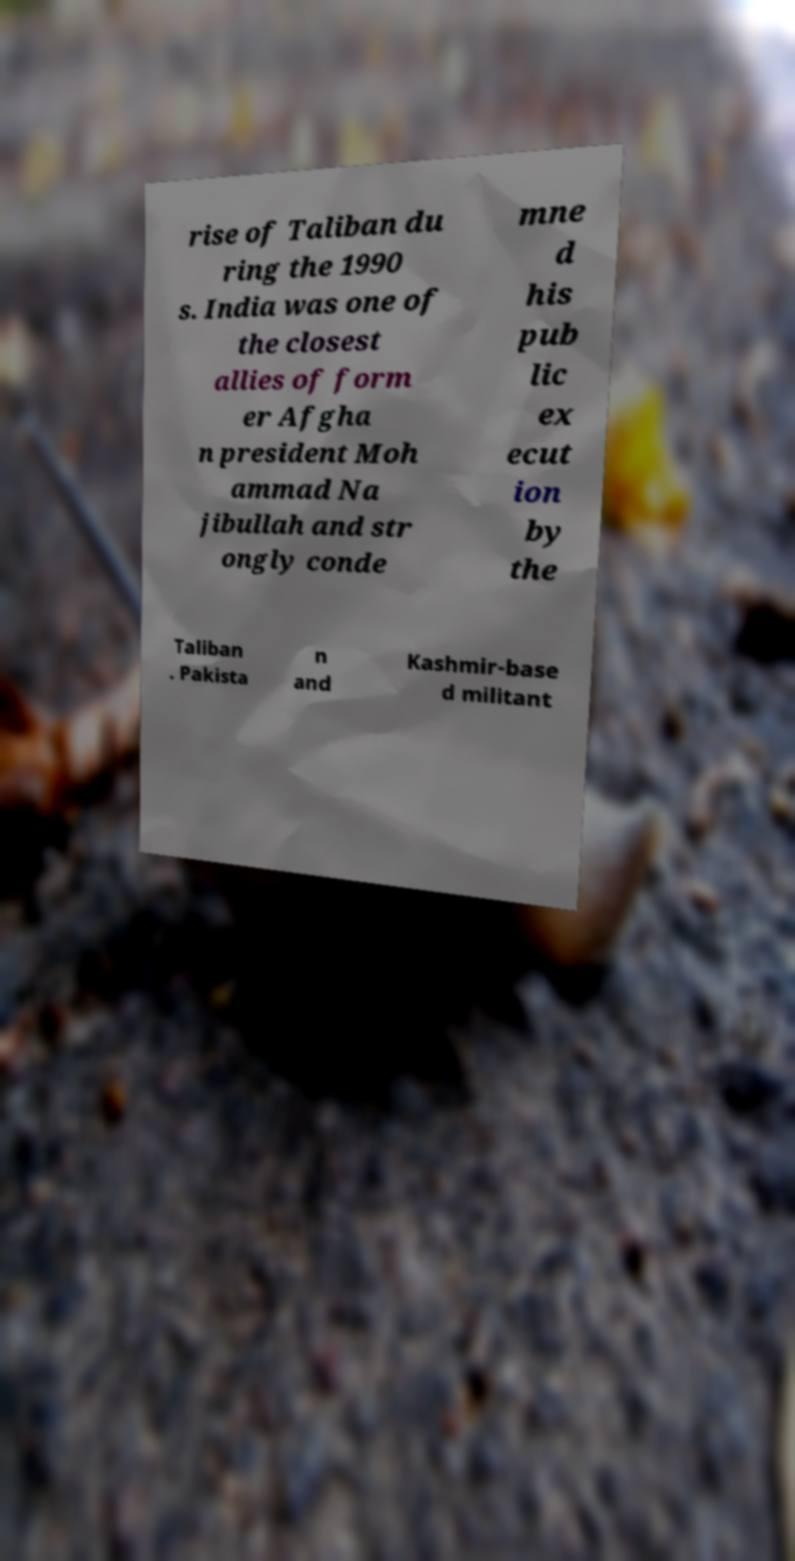There's text embedded in this image that I need extracted. Can you transcribe it verbatim? rise of Taliban du ring the 1990 s. India was one of the closest allies of form er Afgha n president Moh ammad Na jibullah and str ongly conde mne d his pub lic ex ecut ion by the Taliban . Pakista n and Kashmir-base d militant 